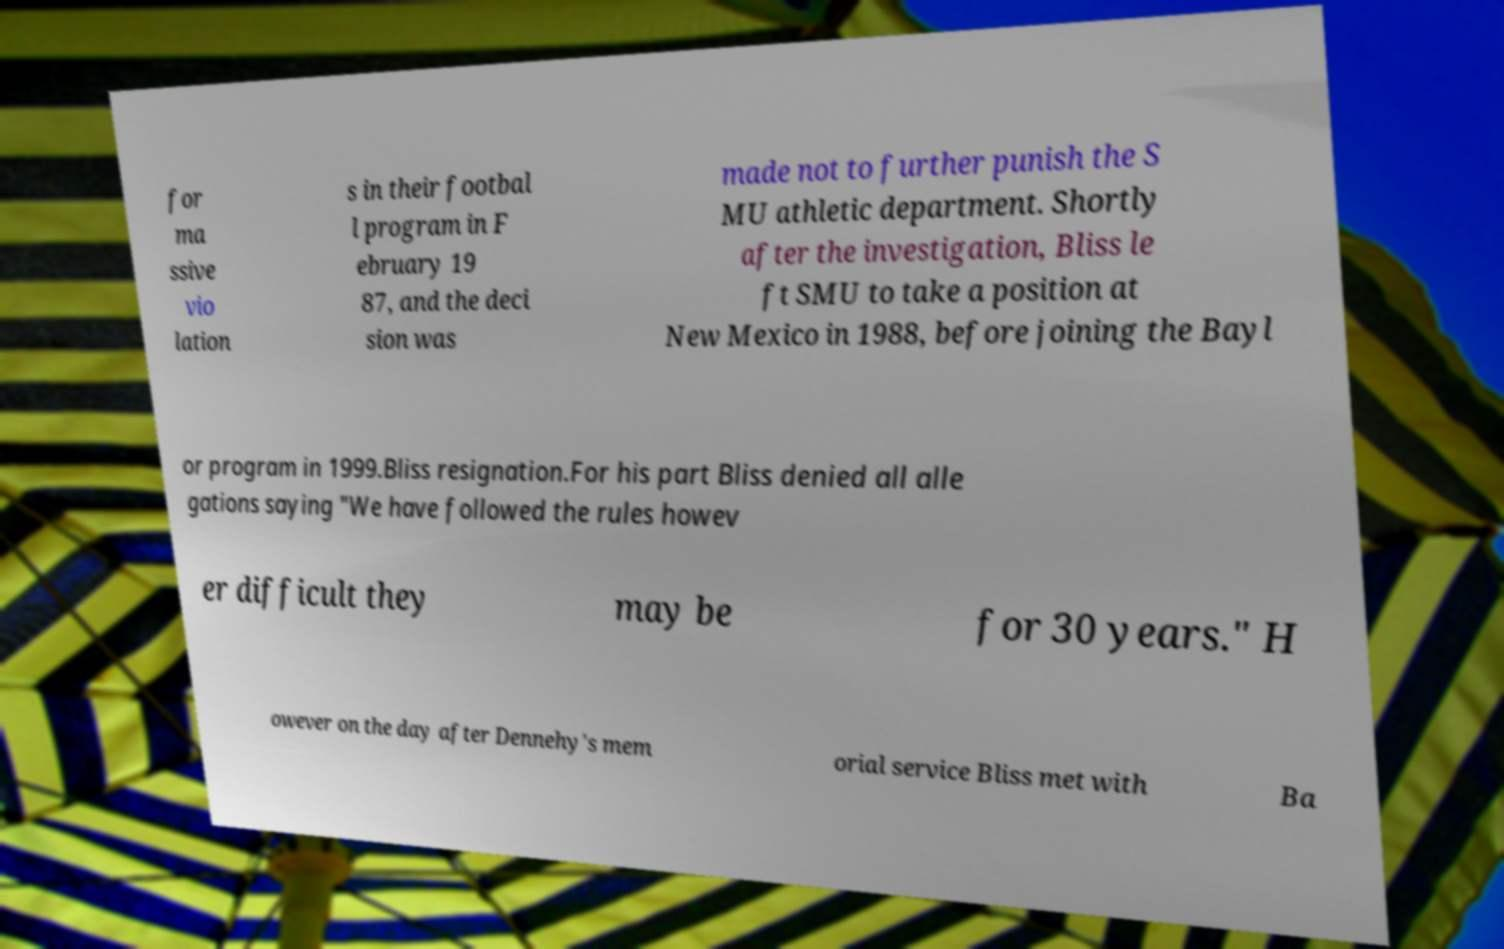What messages or text are displayed in this image? I need them in a readable, typed format. for ma ssive vio lation s in their footbal l program in F ebruary 19 87, and the deci sion was made not to further punish the S MU athletic department. Shortly after the investigation, Bliss le ft SMU to take a position at New Mexico in 1988, before joining the Bayl or program in 1999.Bliss resignation.For his part Bliss denied all alle gations saying "We have followed the rules howev er difficult they may be for 30 years." H owever on the day after Dennehy's mem orial service Bliss met with Ba 